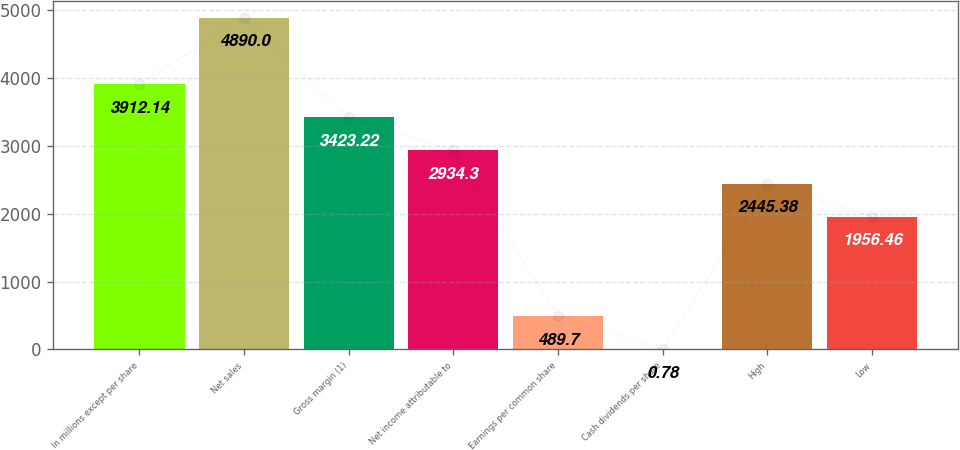<chart> <loc_0><loc_0><loc_500><loc_500><bar_chart><fcel>In millions except per share<fcel>Net sales<fcel>Gross margin (1)<fcel>Net income attributable to<fcel>Earnings per common share<fcel>Cash dividends per share<fcel>High<fcel>Low<nl><fcel>3912.14<fcel>4890<fcel>3423.22<fcel>2934.3<fcel>489.7<fcel>0.78<fcel>2445.38<fcel>1956.46<nl></chart> 